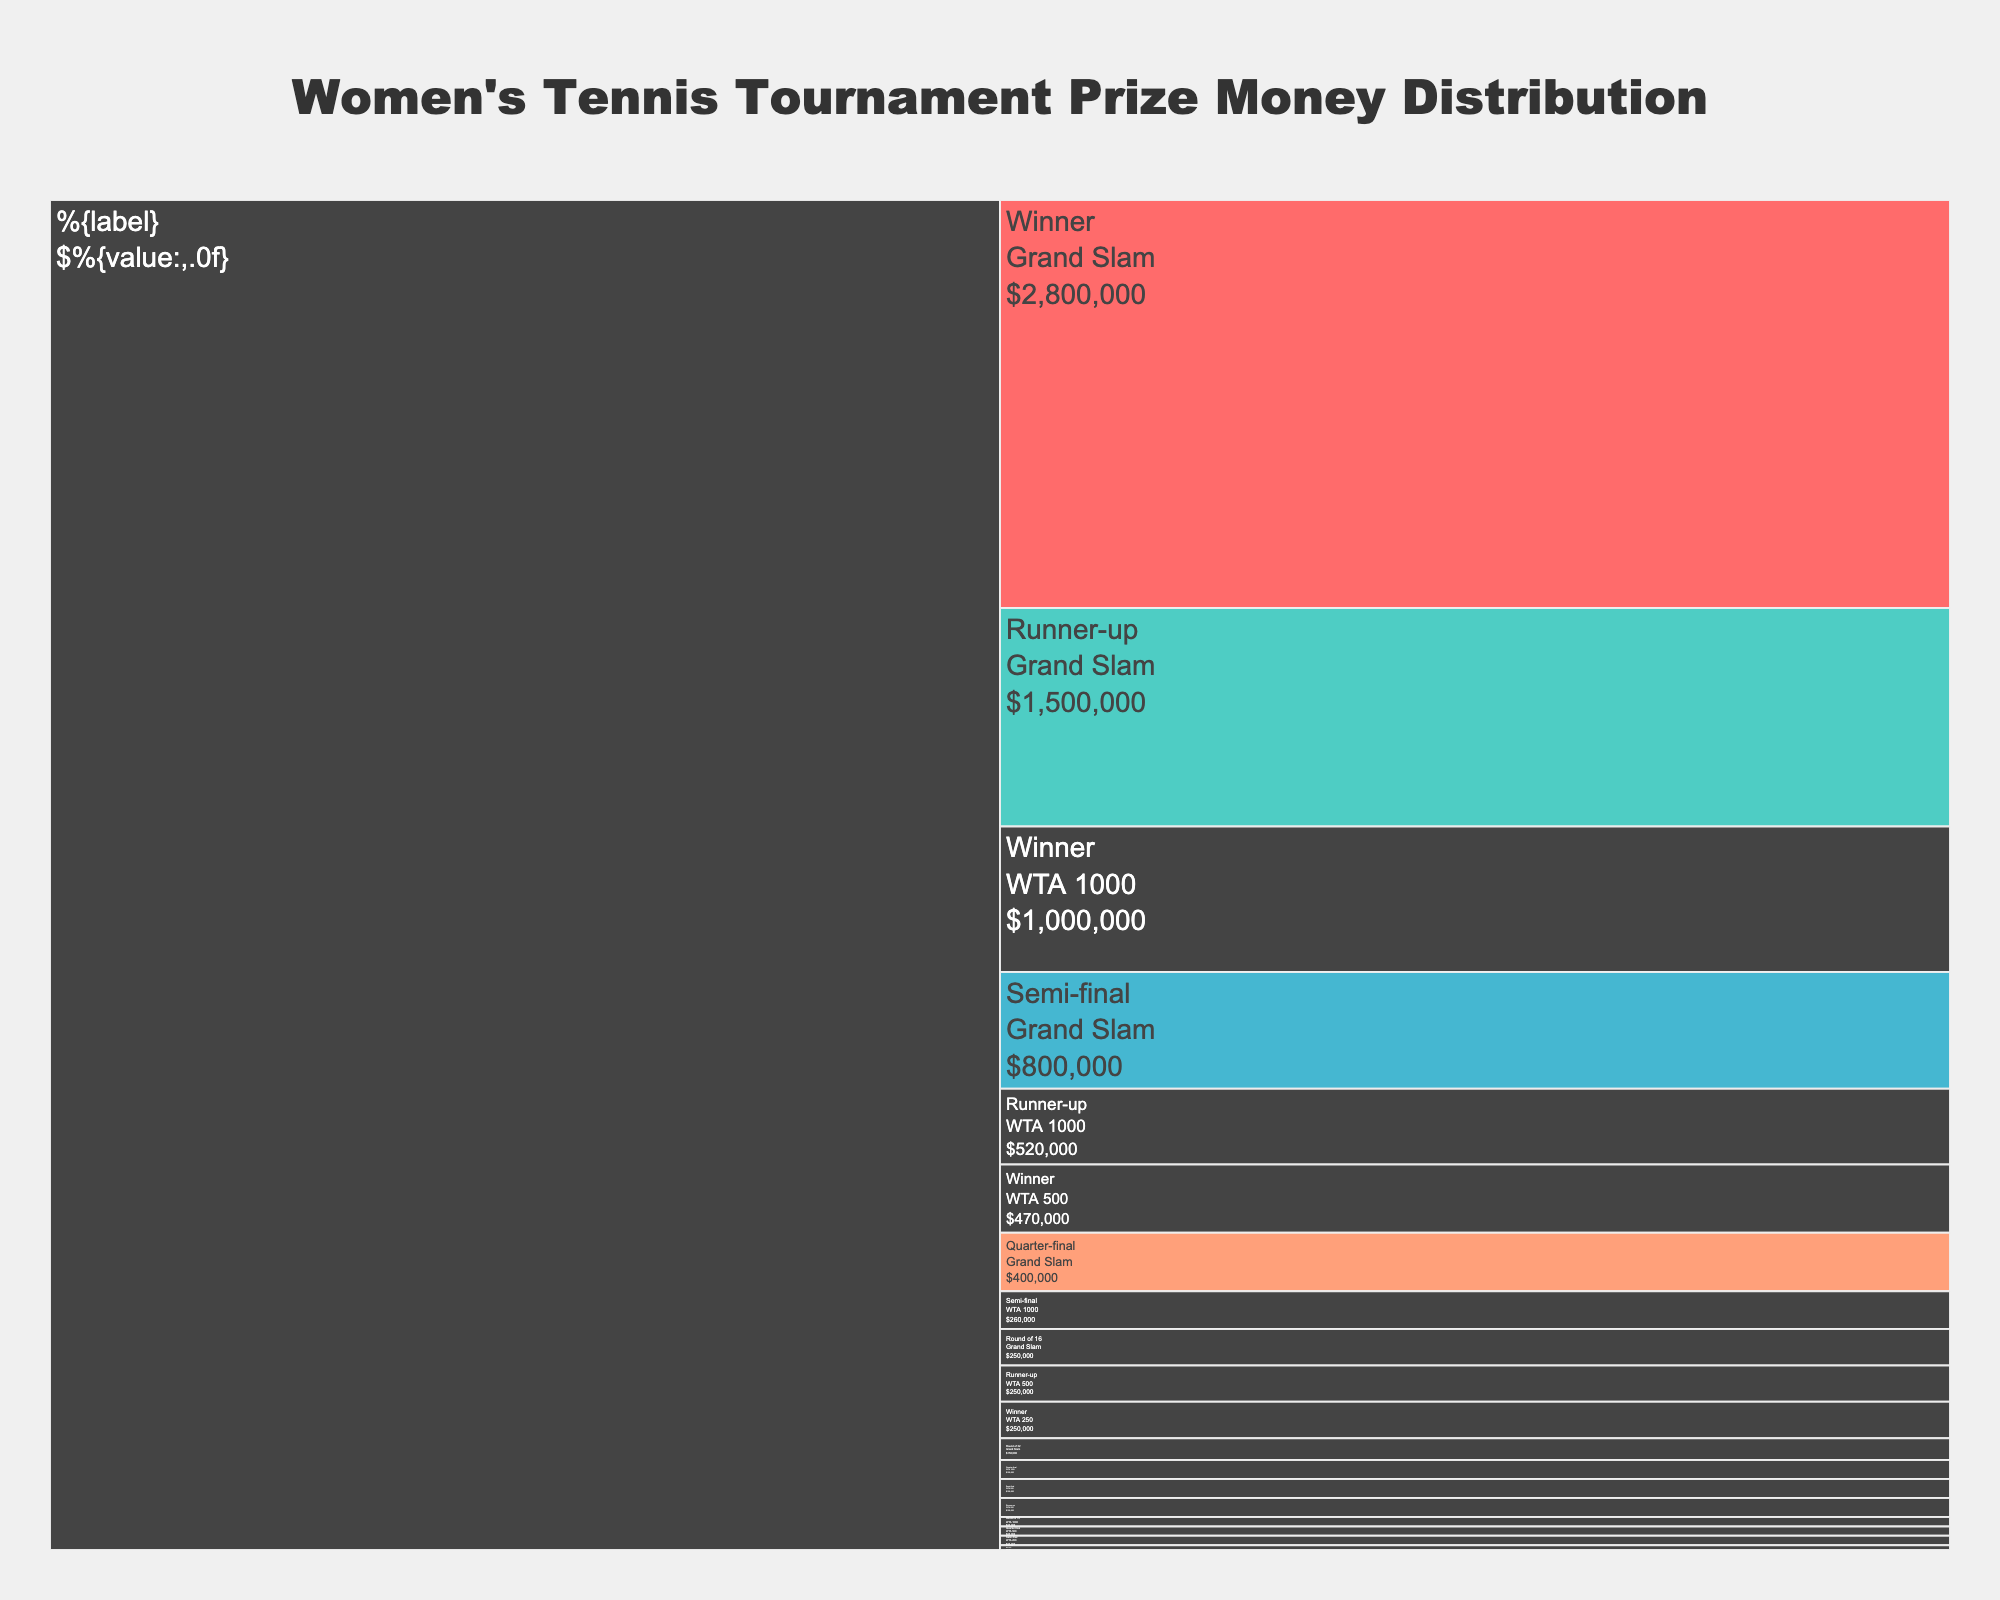What's the title of the icicle chart? The title of an icicle chart is usually placed at the top and is bold and larger in size compared to other text elements. By locating the largest text at the top, we find the title "Women's Tennis Tournament Prize Money Distribution".
Answer: Women's Tennis Tournament Prize Money Distribution Which tournament tier has the highest prize money for the winner? To identify the tournament tier with the highest prize money for the winner, we observe where the "Winner" label shows the maximum value of prize money. We see that the "Grand Slam" tier has the highest value at $2,800,000 for the winner.
Answer: Grand Slam What is the difference in prize money between the winner and runner-up in Grand Slam tournaments? We need to find the prize money for both the "Winner" and "Runner-up" in the Grand Slam category and then calculate the difference. The prize money is $2,800,000 and $1,500,000 respectively. So, $2,800,000 - $1,500,000 gives the difference.
Answer: $1,300,000 Is the prize money for the semifinal of a WTA 500 tournament more or less than the prize money for the quarter-final of a Grand Slam? We locate both the "WTA 500" semifinal and the "Grand Slam" quarter-final prize amounts. The semifinal of the WTA 500 awards $130,000, and the quarter-final of the Grand Slam awards $400,000. Comparing these, we see that $130,000 is less than $400,000.
Answer: Less Among the WTA 1000, WTA 500, and WTA 250 tiers, which tier gives the lowest prize money to the quarter-finalists? We need to find the prize money given to quarter-finalists among the WTA 1000, WTA 500, and WTA 250 tiers. WTA 1000 gives $130,000, WTA 500 gives $65,000, and WTA 250 gives $32,000. The lowest prize money is given by WTA 250.
Answer: WTA 250 What's the sum of the prize money for winners across all tournament tiers? We add up the prize money for winners from each tournament tier: Grand Slam ($2,800,000), WTA 1000 ($1,000,000), WTA 500 ($470,000), and WTA 250 ($250,000). The calculation is $2,800,000 + $1,000,000 + $470,000 + $250,000.
Answer: $4,520,000 What percentage of the total prize money in a Grand Slam does the winner get if the total includes all rounds listed? First, sum the prize money for all rounds in a Grand Slam: $2,800,000 (Winner) + $1,500,000 (Runner-up) + $800,000 (Semi-final) + $400,000 (Quarter-final) + $250,000 (Round of 16) + $150,000 (Round of 32). This total is $5,900,000. The percentage for the winner is then ($2,800,000 / $5,900,000) * 100.
Answer: 47.46% Which round in the WTA 1000 tier has prize money closest to $100,000? By looking at the values for each round in WTA 1000, we see $520,000 (Runner-up), $260,000 (Semi-final), and $130,000 (Quarter-final), and $65,000 (Round of 16). The "Quarter-final" at $130,000 is closest to $100,000.
Answer: Quarter-final How does the prize money for a WTA 250 runner-up compare to a Round of 16 participant in a WTA 1000 tournament? By finding the respective values, the prize money for a WTA 250 runner-up is $130,000, while for the Round of 16 in WTA 1000, it is $65,000. Therefore, $130,000 is greater than $65,000.
Answer: Greater 